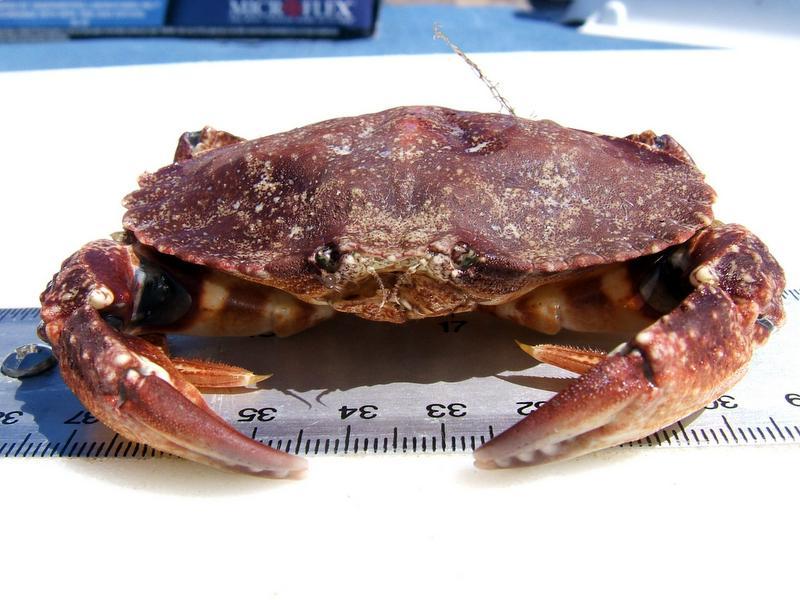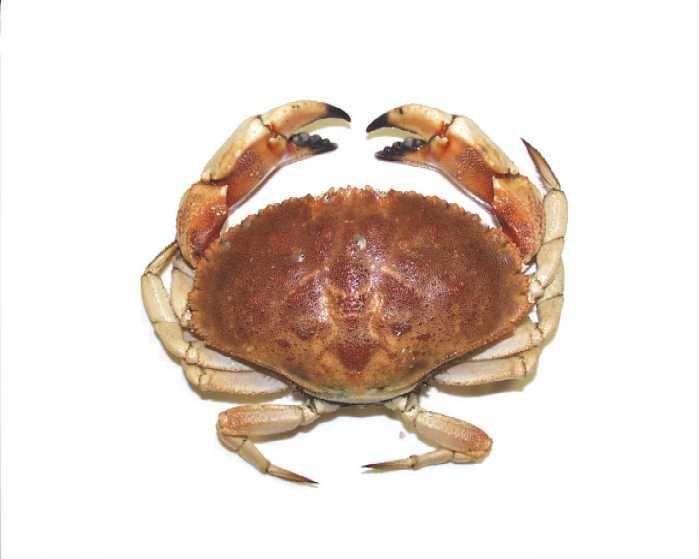The first image is the image on the left, the second image is the image on the right. Assess this claim about the two images: "There are two whole crabs.". Correct or not? Answer yes or no. Yes. 